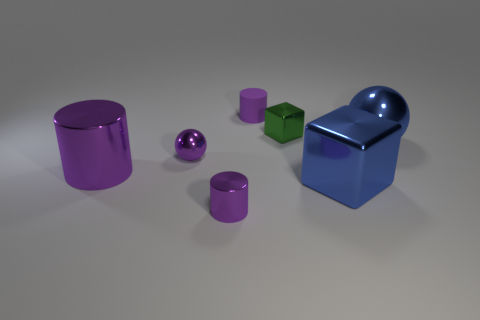How many other objects are the same color as the tiny shiny sphere?
Your response must be concise. 3. How many matte things are brown cubes or big balls?
Your answer should be compact. 0. There is a metallic ball to the right of the matte cylinder; is it the same color as the large metal object on the left side of the tiny purple matte cylinder?
Your answer should be compact. No. Is there any other thing that has the same material as the tiny green block?
Give a very brief answer. Yes. What is the size of the blue thing that is the same shape as the small green object?
Ensure brevity in your answer.  Large. Is the number of big purple things to the right of the large metallic sphere greater than the number of small shiny objects?
Keep it short and to the point. No. Is the material of the purple cylinder that is behind the green cube the same as the large blue block?
Keep it short and to the point. No. How big is the block in front of the block that is behind the metal ball that is to the right of the small green cube?
Keep it short and to the point. Large. What size is the other block that is the same material as the small green cube?
Offer a very short reply. Large. What is the color of the small metallic thing that is behind the tiny metal cylinder and on the left side of the green cube?
Your response must be concise. Purple. 